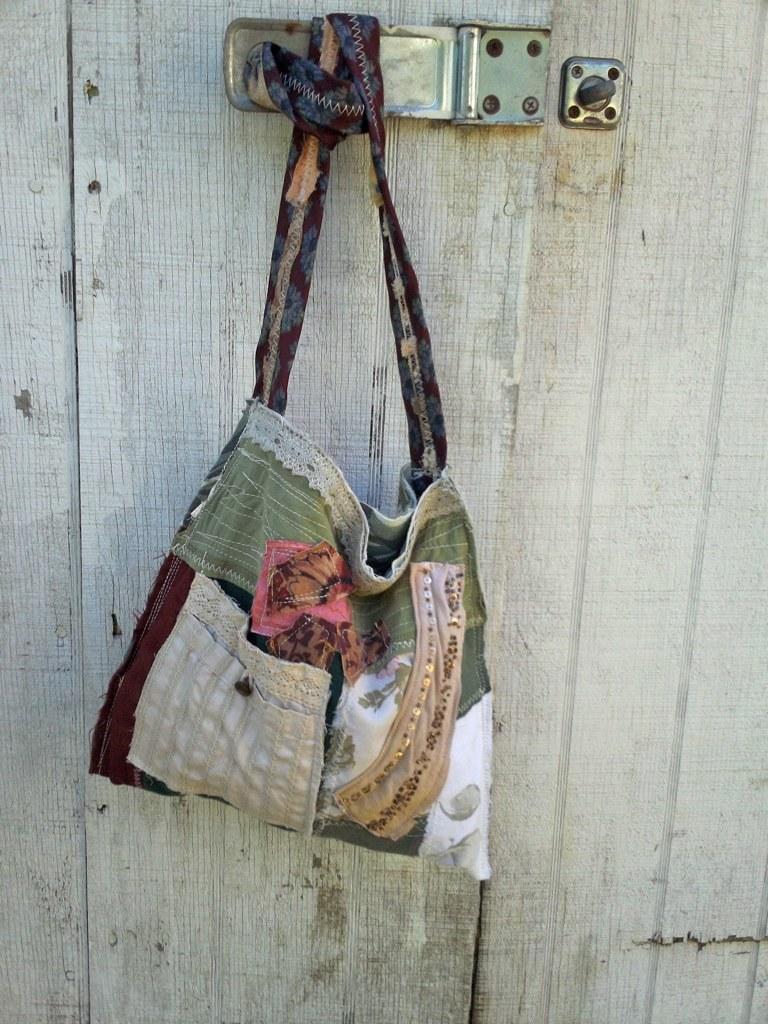Describe this image in one or two sentences. In this image we can see a cloth bag is tied to the handle. We can see a wooden door in the background. 